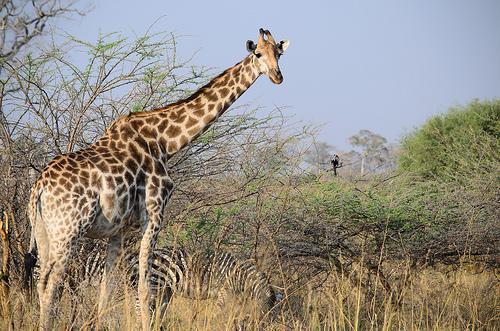How many animals are in the brush?
Give a very brief answer. 2. 